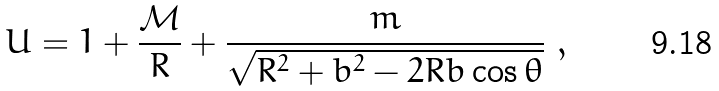<formula> <loc_0><loc_0><loc_500><loc_500>U = 1 + \frac { \mathcal { M } } { R } + \frac { m } { \sqrt { R ^ { 2 } + b ^ { 2 } - 2 R b \cos \theta } } \ ,</formula> 